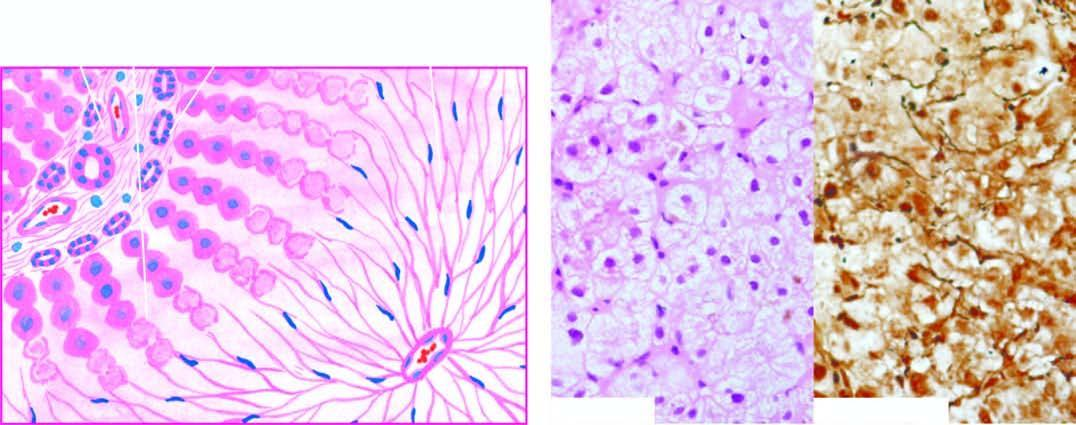there is wiping out of liver lobules with only collapsed reticulin framework left out in whose place , high lighted by reticulin stain right photomicrograph?
Answer the question using a single word or phrase. Their 